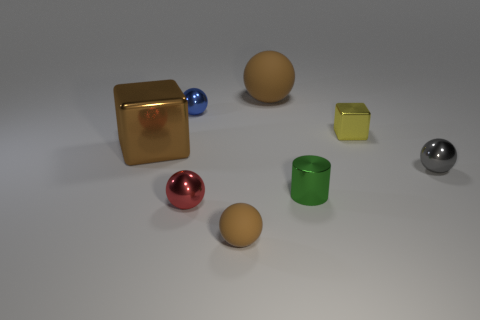The block that is the same color as the big ball is what size?
Give a very brief answer. Large. Are there any big metallic blocks that have the same color as the small rubber object?
Provide a short and direct response. Yes. There is a big cube; is its color the same as the rubber sphere that is behind the tiny gray ball?
Offer a terse response. Yes. There is a rubber object that is in front of the small green thing; is its color the same as the big matte object?
Your answer should be compact. Yes. What is the shape of the small gray object that is made of the same material as the small cylinder?
Ensure brevity in your answer.  Sphere. What number of other objects are the same shape as the tiny blue metallic thing?
Provide a succinct answer. 4. The small gray thing in front of the brown sphere that is behind the brown object that is in front of the tiny green metal object is what shape?
Your response must be concise. Sphere. How many cubes are yellow metallic objects or green objects?
Provide a short and direct response. 1. There is a matte object behind the tiny green cylinder; is there a object that is behind it?
Provide a succinct answer. No. Is there anything else that is made of the same material as the small green cylinder?
Make the answer very short. Yes. 